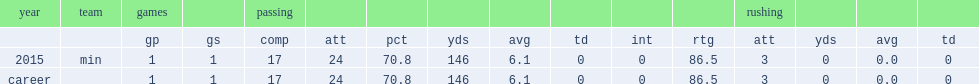How many passing yards did teddy bridgewater get in 2015? 146.0. 